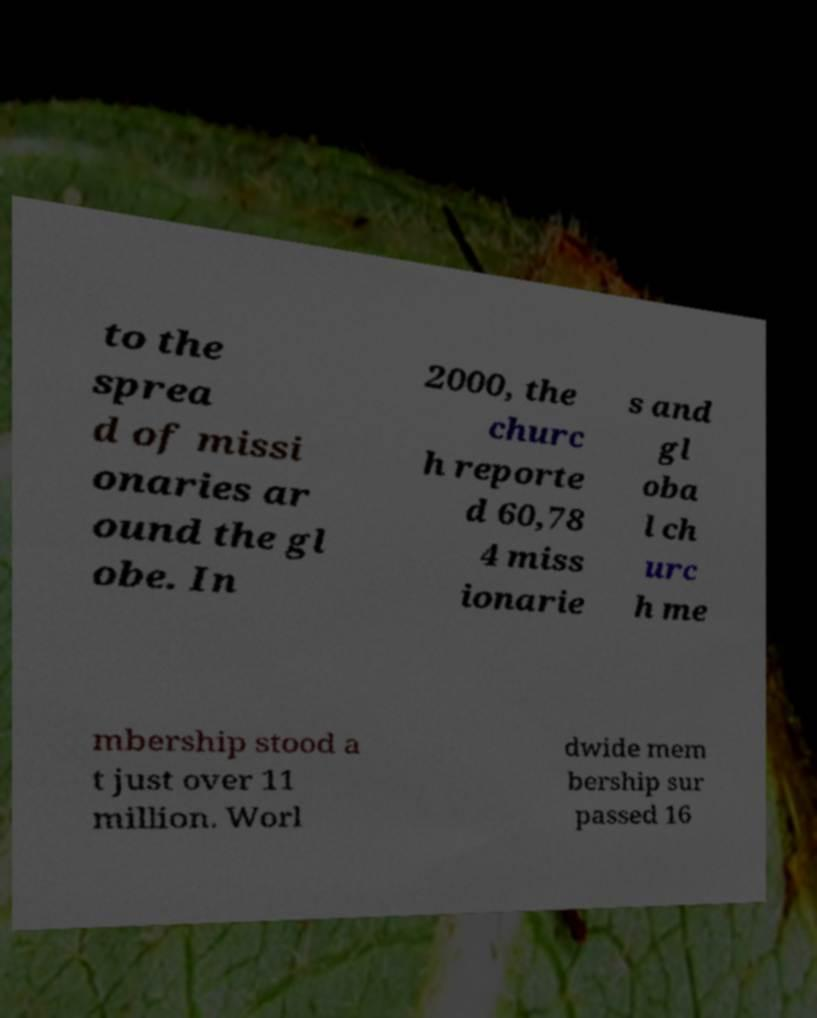Can you read and provide the text displayed in the image?This photo seems to have some interesting text. Can you extract and type it out for me? to the sprea d of missi onaries ar ound the gl obe. In 2000, the churc h reporte d 60,78 4 miss ionarie s and gl oba l ch urc h me mbership stood a t just over 11 million. Worl dwide mem bership sur passed 16 